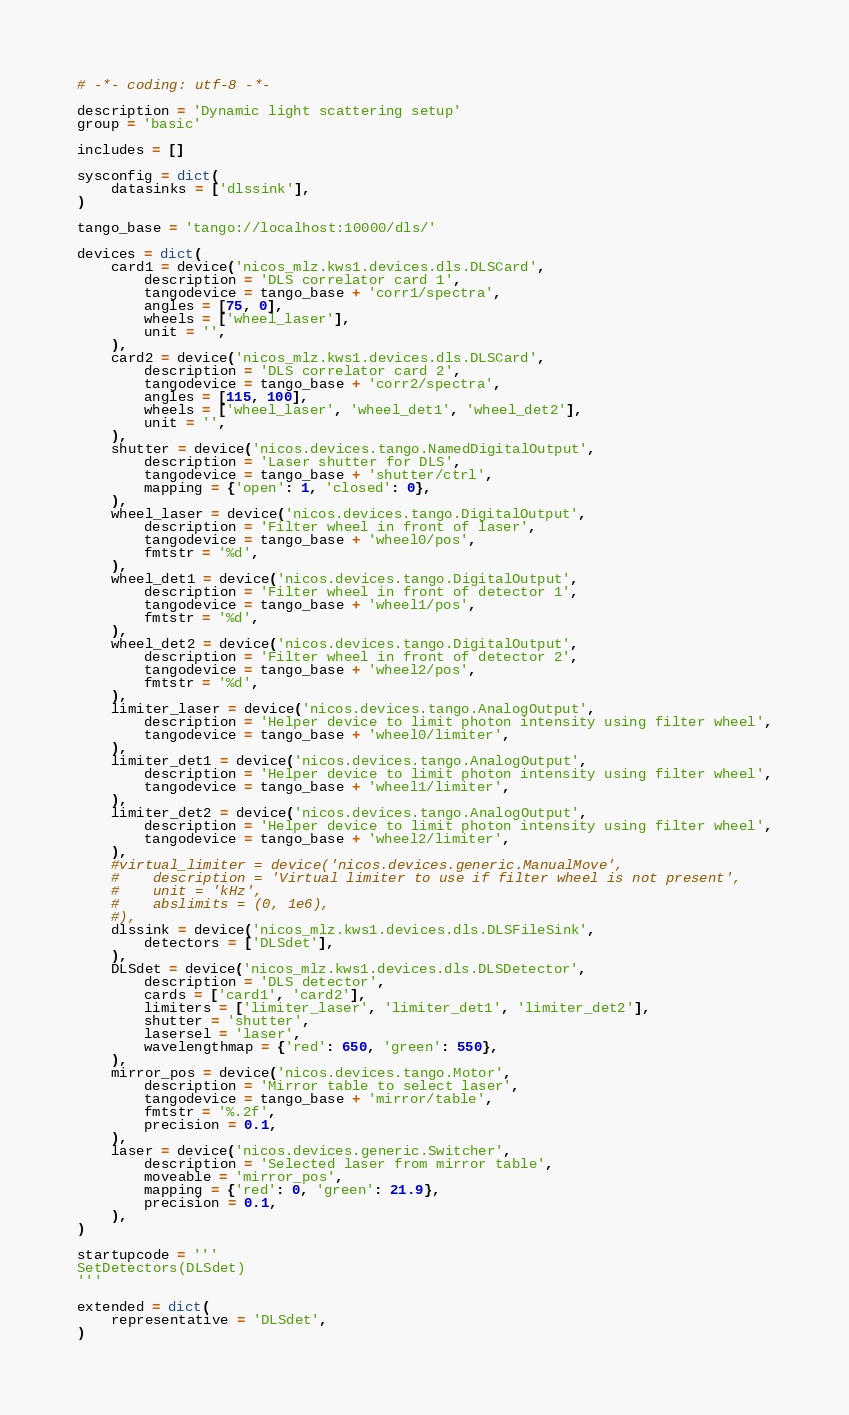Convert code to text. <code><loc_0><loc_0><loc_500><loc_500><_Python_># -*- coding: utf-8 -*-

description = 'Dynamic light scattering setup'
group = 'basic'

includes = []

sysconfig = dict(
    datasinks = ['dlssink'],
)

tango_base = 'tango://localhost:10000/dls/'

devices = dict(
    card1 = device('nicos_mlz.kws1.devices.dls.DLSCard',
        description = 'DLS correlator card 1',
        tangodevice = tango_base + 'corr1/spectra',
        angles = [75, 0],
        wheels = ['wheel_laser'],
        unit = '',
    ),
    card2 = device('nicos_mlz.kws1.devices.dls.DLSCard',
        description = 'DLS correlator card 2',
        tangodevice = tango_base + 'corr2/spectra',
        angles = [115, 100],
        wheels = ['wheel_laser', 'wheel_det1', 'wheel_det2'],
        unit = '',
    ),
    shutter = device('nicos.devices.tango.NamedDigitalOutput',
        description = 'Laser shutter for DLS',
        tangodevice = tango_base + 'shutter/ctrl',
        mapping = {'open': 1, 'closed': 0},
    ),
    wheel_laser = device('nicos.devices.tango.DigitalOutput',
        description = 'Filter wheel in front of laser',
        tangodevice = tango_base + 'wheel0/pos',
        fmtstr = '%d',
    ),
    wheel_det1 = device('nicos.devices.tango.DigitalOutput',
        description = 'Filter wheel in front of detector 1',
        tangodevice = tango_base + 'wheel1/pos',
        fmtstr = '%d',
    ),
    wheel_det2 = device('nicos.devices.tango.DigitalOutput',
        description = 'Filter wheel in front of detector 2',
        tangodevice = tango_base + 'wheel2/pos',
        fmtstr = '%d',
    ),
    limiter_laser = device('nicos.devices.tango.AnalogOutput',
        description = 'Helper device to limit photon intensity using filter wheel',
        tangodevice = tango_base + 'wheel0/limiter',
    ),
    limiter_det1 = device('nicos.devices.tango.AnalogOutput',
        description = 'Helper device to limit photon intensity using filter wheel',
        tangodevice = tango_base + 'wheel1/limiter',
    ),
    limiter_det2 = device('nicos.devices.tango.AnalogOutput',
        description = 'Helper device to limit photon intensity using filter wheel',
        tangodevice = tango_base + 'wheel2/limiter',
    ),
    #virtual_limiter = device('nicos.devices.generic.ManualMove',
    #    description = 'Virtual limiter to use if filter wheel is not present',
    #    unit = 'kHz',
    #    abslimits = (0, 1e6),
    #),
    dlssink = device('nicos_mlz.kws1.devices.dls.DLSFileSink',
        detectors = ['DLSdet'],
    ),
    DLSdet = device('nicos_mlz.kws1.devices.dls.DLSDetector',
        description = 'DLS detector',
        cards = ['card1', 'card2'],
        limiters = ['limiter_laser', 'limiter_det1', 'limiter_det2'],
        shutter = 'shutter',
        lasersel = 'laser',
        wavelengthmap = {'red': 650, 'green': 550},
    ),
    mirror_pos = device('nicos.devices.tango.Motor',
        description = 'Mirror table to select laser',
        tangodevice = tango_base + 'mirror/table',
        fmtstr = '%.2f',
        precision = 0.1,
    ),
    laser = device('nicos.devices.generic.Switcher',
        description = 'Selected laser from mirror table',
        moveable = 'mirror_pos',
        mapping = {'red': 0, 'green': 21.9},
        precision = 0.1,
    ),
)

startupcode = '''
SetDetectors(DLSdet)
'''

extended = dict(
    representative = 'DLSdet',
)
</code> 